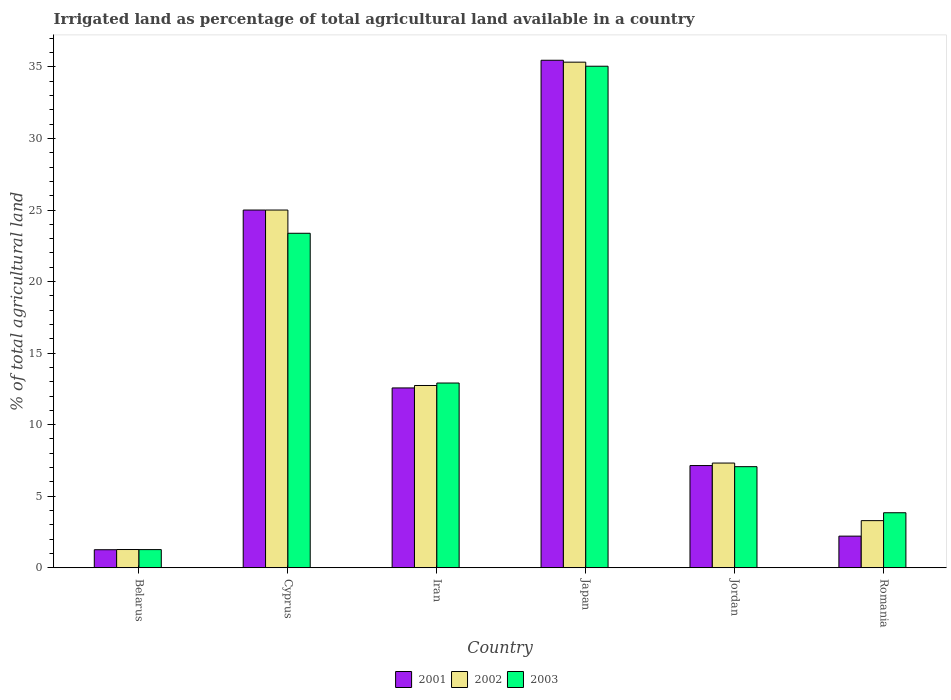How many groups of bars are there?
Give a very brief answer. 6. How many bars are there on the 2nd tick from the left?
Keep it short and to the point. 3. How many bars are there on the 1st tick from the right?
Keep it short and to the point. 3. What is the label of the 2nd group of bars from the left?
Ensure brevity in your answer.  Cyprus. What is the percentage of irrigated land in 2001 in Belarus?
Your response must be concise. 1.26. Across all countries, what is the maximum percentage of irrigated land in 2001?
Your answer should be compact. 35.47. Across all countries, what is the minimum percentage of irrigated land in 2001?
Keep it short and to the point. 1.26. In which country was the percentage of irrigated land in 2002 maximum?
Offer a terse response. Japan. In which country was the percentage of irrigated land in 2002 minimum?
Give a very brief answer. Belarus. What is the total percentage of irrigated land in 2002 in the graph?
Give a very brief answer. 84.96. What is the difference between the percentage of irrigated land in 2001 in Cyprus and that in Iran?
Your answer should be compact. 12.43. What is the difference between the percentage of irrigated land in 2002 in Jordan and the percentage of irrigated land in 2003 in Iran?
Provide a succinct answer. -5.59. What is the average percentage of irrigated land in 2003 per country?
Provide a succinct answer. 13.92. What is the difference between the percentage of irrigated land of/in 2002 and percentage of irrigated land of/in 2001 in Japan?
Your answer should be compact. -0.13. What is the ratio of the percentage of irrigated land in 2001 in Cyprus to that in Jordan?
Offer a terse response. 3.5. What is the difference between the highest and the second highest percentage of irrigated land in 2001?
Your answer should be very brief. -10.47. What is the difference between the highest and the lowest percentage of irrigated land in 2001?
Ensure brevity in your answer.  34.21. What does the 2nd bar from the left in Romania represents?
Make the answer very short. 2002. What does the 3rd bar from the right in Jordan represents?
Offer a very short reply. 2001. What is the difference between two consecutive major ticks on the Y-axis?
Make the answer very short. 5. Are the values on the major ticks of Y-axis written in scientific E-notation?
Keep it short and to the point. No. Does the graph contain any zero values?
Offer a terse response. No. Does the graph contain grids?
Your answer should be very brief. No. Where does the legend appear in the graph?
Ensure brevity in your answer.  Bottom center. What is the title of the graph?
Provide a succinct answer. Irrigated land as percentage of total agricultural land available in a country. What is the label or title of the Y-axis?
Provide a short and direct response. % of total agricultural land. What is the % of total agricultural land of 2001 in Belarus?
Offer a very short reply. 1.26. What is the % of total agricultural land in 2002 in Belarus?
Make the answer very short. 1.27. What is the % of total agricultural land of 2003 in Belarus?
Your response must be concise. 1.27. What is the % of total agricultural land in 2002 in Cyprus?
Offer a terse response. 25. What is the % of total agricultural land of 2003 in Cyprus?
Offer a very short reply. 23.38. What is the % of total agricultural land of 2001 in Iran?
Offer a terse response. 12.57. What is the % of total agricultural land of 2002 in Iran?
Ensure brevity in your answer.  12.74. What is the % of total agricultural land in 2003 in Iran?
Provide a succinct answer. 12.91. What is the % of total agricultural land of 2001 in Japan?
Keep it short and to the point. 35.47. What is the % of total agricultural land of 2002 in Japan?
Provide a short and direct response. 35.33. What is the % of total agricultural land in 2003 in Japan?
Give a very brief answer. 35.05. What is the % of total agricultural land in 2001 in Jordan?
Ensure brevity in your answer.  7.14. What is the % of total agricultural land of 2002 in Jordan?
Provide a short and direct response. 7.32. What is the % of total agricultural land of 2003 in Jordan?
Provide a succinct answer. 7.06. What is the % of total agricultural land of 2001 in Romania?
Provide a succinct answer. 2.21. What is the % of total agricultural land of 2002 in Romania?
Your answer should be very brief. 3.29. What is the % of total agricultural land of 2003 in Romania?
Make the answer very short. 3.84. Across all countries, what is the maximum % of total agricultural land of 2001?
Provide a short and direct response. 35.47. Across all countries, what is the maximum % of total agricultural land of 2002?
Offer a very short reply. 35.33. Across all countries, what is the maximum % of total agricultural land of 2003?
Your answer should be very brief. 35.05. Across all countries, what is the minimum % of total agricultural land in 2001?
Your answer should be compact. 1.26. Across all countries, what is the minimum % of total agricultural land in 2002?
Your response must be concise. 1.27. Across all countries, what is the minimum % of total agricultural land in 2003?
Keep it short and to the point. 1.27. What is the total % of total agricultural land of 2001 in the graph?
Keep it short and to the point. 83.65. What is the total % of total agricultural land in 2002 in the graph?
Keep it short and to the point. 84.96. What is the total % of total agricultural land of 2003 in the graph?
Offer a very short reply. 83.52. What is the difference between the % of total agricultural land in 2001 in Belarus and that in Cyprus?
Provide a succinct answer. -23.74. What is the difference between the % of total agricultural land of 2002 in Belarus and that in Cyprus?
Provide a short and direct response. -23.73. What is the difference between the % of total agricultural land in 2003 in Belarus and that in Cyprus?
Provide a short and direct response. -22.11. What is the difference between the % of total agricultural land of 2001 in Belarus and that in Iran?
Your response must be concise. -11.31. What is the difference between the % of total agricultural land of 2002 in Belarus and that in Iran?
Your answer should be compact. -11.46. What is the difference between the % of total agricultural land in 2003 in Belarus and that in Iran?
Provide a succinct answer. -11.64. What is the difference between the % of total agricultural land in 2001 in Belarus and that in Japan?
Provide a short and direct response. -34.21. What is the difference between the % of total agricultural land in 2002 in Belarus and that in Japan?
Give a very brief answer. -34.06. What is the difference between the % of total agricultural land of 2003 in Belarus and that in Japan?
Keep it short and to the point. -33.78. What is the difference between the % of total agricultural land of 2001 in Belarus and that in Jordan?
Offer a very short reply. -5.88. What is the difference between the % of total agricultural land of 2002 in Belarus and that in Jordan?
Ensure brevity in your answer.  -6.04. What is the difference between the % of total agricultural land in 2003 in Belarus and that in Jordan?
Keep it short and to the point. -5.8. What is the difference between the % of total agricultural land of 2001 in Belarus and that in Romania?
Your response must be concise. -0.95. What is the difference between the % of total agricultural land in 2002 in Belarus and that in Romania?
Provide a succinct answer. -2.02. What is the difference between the % of total agricultural land of 2003 in Belarus and that in Romania?
Ensure brevity in your answer.  -2.58. What is the difference between the % of total agricultural land in 2001 in Cyprus and that in Iran?
Your response must be concise. 12.43. What is the difference between the % of total agricultural land of 2002 in Cyprus and that in Iran?
Ensure brevity in your answer.  12.26. What is the difference between the % of total agricultural land in 2003 in Cyprus and that in Iran?
Offer a very short reply. 10.47. What is the difference between the % of total agricultural land in 2001 in Cyprus and that in Japan?
Make the answer very short. -10.47. What is the difference between the % of total agricultural land in 2002 in Cyprus and that in Japan?
Give a very brief answer. -10.33. What is the difference between the % of total agricultural land of 2003 in Cyprus and that in Japan?
Keep it short and to the point. -11.67. What is the difference between the % of total agricultural land in 2001 in Cyprus and that in Jordan?
Make the answer very short. 17.86. What is the difference between the % of total agricultural land of 2002 in Cyprus and that in Jordan?
Make the answer very short. 17.68. What is the difference between the % of total agricultural land of 2003 in Cyprus and that in Jordan?
Provide a succinct answer. 16.31. What is the difference between the % of total agricultural land of 2001 in Cyprus and that in Romania?
Your response must be concise. 22.79. What is the difference between the % of total agricultural land in 2002 in Cyprus and that in Romania?
Make the answer very short. 21.71. What is the difference between the % of total agricultural land of 2003 in Cyprus and that in Romania?
Offer a very short reply. 19.53. What is the difference between the % of total agricultural land of 2001 in Iran and that in Japan?
Ensure brevity in your answer.  -22.9. What is the difference between the % of total agricultural land in 2002 in Iran and that in Japan?
Ensure brevity in your answer.  -22.6. What is the difference between the % of total agricultural land in 2003 in Iran and that in Japan?
Ensure brevity in your answer.  -22.14. What is the difference between the % of total agricultural land in 2001 in Iran and that in Jordan?
Make the answer very short. 5.42. What is the difference between the % of total agricultural land of 2002 in Iran and that in Jordan?
Make the answer very short. 5.42. What is the difference between the % of total agricultural land in 2003 in Iran and that in Jordan?
Offer a terse response. 5.85. What is the difference between the % of total agricultural land in 2001 in Iran and that in Romania?
Keep it short and to the point. 10.36. What is the difference between the % of total agricultural land of 2002 in Iran and that in Romania?
Offer a very short reply. 9.44. What is the difference between the % of total agricultural land in 2003 in Iran and that in Romania?
Your answer should be very brief. 9.07. What is the difference between the % of total agricultural land of 2001 in Japan and that in Jordan?
Your answer should be very brief. 28.33. What is the difference between the % of total agricultural land in 2002 in Japan and that in Jordan?
Ensure brevity in your answer.  28.02. What is the difference between the % of total agricultural land of 2003 in Japan and that in Jordan?
Make the answer very short. 27.99. What is the difference between the % of total agricultural land of 2001 in Japan and that in Romania?
Offer a terse response. 33.26. What is the difference between the % of total agricultural land of 2002 in Japan and that in Romania?
Your answer should be very brief. 32.04. What is the difference between the % of total agricultural land in 2003 in Japan and that in Romania?
Your response must be concise. 31.21. What is the difference between the % of total agricultural land of 2001 in Jordan and that in Romania?
Your answer should be very brief. 4.93. What is the difference between the % of total agricultural land of 2002 in Jordan and that in Romania?
Make the answer very short. 4.02. What is the difference between the % of total agricultural land in 2003 in Jordan and that in Romania?
Your answer should be very brief. 3.22. What is the difference between the % of total agricultural land of 2001 in Belarus and the % of total agricultural land of 2002 in Cyprus?
Give a very brief answer. -23.74. What is the difference between the % of total agricultural land in 2001 in Belarus and the % of total agricultural land in 2003 in Cyprus?
Make the answer very short. -22.12. What is the difference between the % of total agricultural land in 2002 in Belarus and the % of total agricultural land in 2003 in Cyprus?
Make the answer very short. -22.1. What is the difference between the % of total agricultural land of 2001 in Belarus and the % of total agricultural land of 2002 in Iran?
Make the answer very short. -11.48. What is the difference between the % of total agricultural land of 2001 in Belarus and the % of total agricultural land of 2003 in Iran?
Provide a succinct answer. -11.65. What is the difference between the % of total agricultural land in 2002 in Belarus and the % of total agricultural land in 2003 in Iran?
Provide a succinct answer. -11.64. What is the difference between the % of total agricultural land of 2001 in Belarus and the % of total agricultural land of 2002 in Japan?
Give a very brief answer. -34.08. What is the difference between the % of total agricultural land of 2001 in Belarus and the % of total agricultural land of 2003 in Japan?
Your answer should be very brief. -33.79. What is the difference between the % of total agricultural land in 2002 in Belarus and the % of total agricultural land in 2003 in Japan?
Give a very brief answer. -33.78. What is the difference between the % of total agricultural land in 2001 in Belarus and the % of total agricultural land in 2002 in Jordan?
Ensure brevity in your answer.  -6.06. What is the difference between the % of total agricultural land of 2001 in Belarus and the % of total agricultural land of 2003 in Jordan?
Give a very brief answer. -5.8. What is the difference between the % of total agricultural land of 2002 in Belarus and the % of total agricultural land of 2003 in Jordan?
Give a very brief answer. -5.79. What is the difference between the % of total agricultural land in 2001 in Belarus and the % of total agricultural land in 2002 in Romania?
Your response must be concise. -2.03. What is the difference between the % of total agricultural land of 2001 in Belarus and the % of total agricultural land of 2003 in Romania?
Give a very brief answer. -2.58. What is the difference between the % of total agricultural land in 2002 in Belarus and the % of total agricultural land in 2003 in Romania?
Your answer should be compact. -2.57. What is the difference between the % of total agricultural land of 2001 in Cyprus and the % of total agricultural land of 2002 in Iran?
Give a very brief answer. 12.26. What is the difference between the % of total agricultural land of 2001 in Cyprus and the % of total agricultural land of 2003 in Iran?
Offer a terse response. 12.09. What is the difference between the % of total agricultural land of 2002 in Cyprus and the % of total agricultural land of 2003 in Iran?
Give a very brief answer. 12.09. What is the difference between the % of total agricultural land of 2001 in Cyprus and the % of total agricultural land of 2002 in Japan?
Keep it short and to the point. -10.33. What is the difference between the % of total agricultural land in 2001 in Cyprus and the % of total agricultural land in 2003 in Japan?
Your answer should be compact. -10.05. What is the difference between the % of total agricultural land in 2002 in Cyprus and the % of total agricultural land in 2003 in Japan?
Make the answer very short. -10.05. What is the difference between the % of total agricultural land in 2001 in Cyprus and the % of total agricultural land in 2002 in Jordan?
Your answer should be very brief. 17.68. What is the difference between the % of total agricultural land in 2001 in Cyprus and the % of total agricultural land in 2003 in Jordan?
Your response must be concise. 17.94. What is the difference between the % of total agricultural land in 2002 in Cyprus and the % of total agricultural land in 2003 in Jordan?
Provide a succinct answer. 17.94. What is the difference between the % of total agricultural land in 2001 in Cyprus and the % of total agricultural land in 2002 in Romania?
Your answer should be very brief. 21.71. What is the difference between the % of total agricultural land in 2001 in Cyprus and the % of total agricultural land in 2003 in Romania?
Provide a short and direct response. 21.16. What is the difference between the % of total agricultural land of 2002 in Cyprus and the % of total agricultural land of 2003 in Romania?
Your answer should be very brief. 21.16. What is the difference between the % of total agricultural land in 2001 in Iran and the % of total agricultural land in 2002 in Japan?
Keep it short and to the point. -22.77. What is the difference between the % of total agricultural land in 2001 in Iran and the % of total agricultural land in 2003 in Japan?
Give a very brief answer. -22.48. What is the difference between the % of total agricultural land in 2002 in Iran and the % of total agricultural land in 2003 in Japan?
Keep it short and to the point. -22.31. What is the difference between the % of total agricultural land in 2001 in Iran and the % of total agricultural land in 2002 in Jordan?
Your answer should be compact. 5.25. What is the difference between the % of total agricultural land in 2001 in Iran and the % of total agricultural land in 2003 in Jordan?
Your response must be concise. 5.5. What is the difference between the % of total agricultural land of 2002 in Iran and the % of total agricultural land of 2003 in Jordan?
Your answer should be compact. 5.67. What is the difference between the % of total agricultural land of 2001 in Iran and the % of total agricultural land of 2002 in Romania?
Offer a terse response. 9.27. What is the difference between the % of total agricultural land in 2001 in Iran and the % of total agricultural land in 2003 in Romania?
Your response must be concise. 8.72. What is the difference between the % of total agricultural land of 2002 in Iran and the % of total agricultural land of 2003 in Romania?
Keep it short and to the point. 8.89. What is the difference between the % of total agricultural land of 2001 in Japan and the % of total agricultural land of 2002 in Jordan?
Your response must be concise. 28.15. What is the difference between the % of total agricultural land of 2001 in Japan and the % of total agricultural land of 2003 in Jordan?
Ensure brevity in your answer.  28.4. What is the difference between the % of total agricultural land of 2002 in Japan and the % of total agricultural land of 2003 in Jordan?
Make the answer very short. 28.27. What is the difference between the % of total agricultural land in 2001 in Japan and the % of total agricultural land in 2002 in Romania?
Your answer should be compact. 32.18. What is the difference between the % of total agricultural land of 2001 in Japan and the % of total agricultural land of 2003 in Romania?
Provide a succinct answer. 31.62. What is the difference between the % of total agricultural land of 2002 in Japan and the % of total agricultural land of 2003 in Romania?
Your answer should be very brief. 31.49. What is the difference between the % of total agricultural land in 2001 in Jordan and the % of total agricultural land in 2002 in Romania?
Give a very brief answer. 3.85. What is the difference between the % of total agricultural land of 2001 in Jordan and the % of total agricultural land of 2003 in Romania?
Your answer should be very brief. 3.3. What is the difference between the % of total agricultural land in 2002 in Jordan and the % of total agricultural land in 2003 in Romania?
Give a very brief answer. 3.47. What is the average % of total agricultural land of 2001 per country?
Your response must be concise. 13.94. What is the average % of total agricultural land of 2002 per country?
Keep it short and to the point. 14.16. What is the average % of total agricultural land of 2003 per country?
Ensure brevity in your answer.  13.92. What is the difference between the % of total agricultural land of 2001 and % of total agricultural land of 2002 in Belarus?
Offer a very short reply. -0.01. What is the difference between the % of total agricultural land in 2001 and % of total agricultural land in 2003 in Belarus?
Offer a terse response. -0.01. What is the difference between the % of total agricultural land of 2002 and % of total agricultural land of 2003 in Belarus?
Your response must be concise. 0.01. What is the difference between the % of total agricultural land of 2001 and % of total agricultural land of 2003 in Cyprus?
Your response must be concise. 1.62. What is the difference between the % of total agricultural land of 2002 and % of total agricultural land of 2003 in Cyprus?
Offer a terse response. 1.62. What is the difference between the % of total agricultural land of 2001 and % of total agricultural land of 2002 in Iran?
Offer a terse response. -0.17. What is the difference between the % of total agricultural land of 2001 and % of total agricultural land of 2003 in Iran?
Your response must be concise. -0.34. What is the difference between the % of total agricultural land of 2002 and % of total agricultural land of 2003 in Iran?
Ensure brevity in your answer.  -0.17. What is the difference between the % of total agricultural land in 2001 and % of total agricultural land in 2002 in Japan?
Your answer should be compact. 0.13. What is the difference between the % of total agricultural land in 2001 and % of total agricultural land in 2003 in Japan?
Your answer should be compact. 0.42. What is the difference between the % of total agricultural land in 2002 and % of total agricultural land in 2003 in Japan?
Provide a succinct answer. 0.28. What is the difference between the % of total agricultural land of 2001 and % of total agricultural land of 2002 in Jordan?
Provide a succinct answer. -0.17. What is the difference between the % of total agricultural land in 2001 and % of total agricultural land in 2003 in Jordan?
Ensure brevity in your answer.  0.08. What is the difference between the % of total agricultural land in 2002 and % of total agricultural land in 2003 in Jordan?
Keep it short and to the point. 0.25. What is the difference between the % of total agricultural land of 2001 and % of total agricultural land of 2002 in Romania?
Your response must be concise. -1.08. What is the difference between the % of total agricultural land in 2001 and % of total agricultural land in 2003 in Romania?
Your response must be concise. -1.63. What is the difference between the % of total agricultural land in 2002 and % of total agricultural land in 2003 in Romania?
Your response must be concise. -0.55. What is the ratio of the % of total agricultural land in 2001 in Belarus to that in Cyprus?
Offer a terse response. 0.05. What is the ratio of the % of total agricultural land of 2002 in Belarus to that in Cyprus?
Give a very brief answer. 0.05. What is the ratio of the % of total agricultural land in 2003 in Belarus to that in Cyprus?
Your answer should be compact. 0.05. What is the ratio of the % of total agricultural land in 2001 in Belarus to that in Iran?
Offer a terse response. 0.1. What is the ratio of the % of total agricultural land of 2003 in Belarus to that in Iran?
Ensure brevity in your answer.  0.1. What is the ratio of the % of total agricultural land in 2001 in Belarus to that in Japan?
Offer a very short reply. 0.04. What is the ratio of the % of total agricultural land of 2002 in Belarus to that in Japan?
Your answer should be very brief. 0.04. What is the ratio of the % of total agricultural land of 2003 in Belarus to that in Japan?
Make the answer very short. 0.04. What is the ratio of the % of total agricultural land of 2001 in Belarus to that in Jordan?
Your answer should be very brief. 0.18. What is the ratio of the % of total agricultural land of 2002 in Belarus to that in Jordan?
Provide a succinct answer. 0.17. What is the ratio of the % of total agricultural land of 2003 in Belarus to that in Jordan?
Keep it short and to the point. 0.18. What is the ratio of the % of total agricultural land in 2001 in Belarus to that in Romania?
Provide a short and direct response. 0.57. What is the ratio of the % of total agricultural land of 2002 in Belarus to that in Romania?
Your response must be concise. 0.39. What is the ratio of the % of total agricultural land of 2003 in Belarus to that in Romania?
Give a very brief answer. 0.33. What is the ratio of the % of total agricultural land in 2001 in Cyprus to that in Iran?
Provide a short and direct response. 1.99. What is the ratio of the % of total agricultural land in 2002 in Cyprus to that in Iran?
Keep it short and to the point. 1.96. What is the ratio of the % of total agricultural land of 2003 in Cyprus to that in Iran?
Your answer should be compact. 1.81. What is the ratio of the % of total agricultural land in 2001 in Cyprus to that in Japan?
Give a very brief answer. 0.7. What is the ratio of the % of total agricultural land in 2002 in Cyprus to that in Japan?
Your response must be concise. 0.71. What is the ratio of the % of total agricultural land in 2003 in Cyprus to that in Japan?
Offer a terse response. 0.67. What is the ratio of the % of total agricultural land in 2002 in Cyprus to that in Jordan?
Your answer should be compact. 3.42. What is the ratio of the % of total agricultural land of 2003 in Cyprus to that in Jordan?
Give a very brief answer. 3.31. What is the ratio of the % of total agricultural land of 2001 in Cyprus to that in Romania?
Offer a very short reply. 11.31. What is the ratio of the % of total agricultural land of 2002 in Cyprus to that in Romania?
Provide a short and direct response. 7.59. What is the ratio of the % of total agricultural land in 2003 in Cyprus to that in Romania?
Offer a very short reply. 6.08. What is the ratio of the % of total agricultural land in 2001 in Iran to that in Japan?
Your answer should be very brief. 0.35. What is the ratio of the % of total agricultural land of 2002 in Iran to that in Japan?
Provide a short and direct response. 0.36. What is the ratio of the % of total agricultural land of 2003 in Iran to that in Japan?
Provide a short and direct response. 0.37. What is the ratio of the % of total agricultural land of 2001 in Iran to that in Jordan?
Provide a succinct answer. 1.76. What is the ratio of the % of total agricultural land in 2002 in Iran to that in Jordan?
Keep it short and to the point. 1.74. What is the ratio of the % of total agricultural land in 2003 in Iran to that in Jordan?
Make the answer very short. 1.83. What is the ratio of the % of total agricultural land of 2001 in Iran to that in Romania?
Make the answer very short. 5.69. What is the ratio of the % of total agricultural land in 2002 in Iran to that in Romania?
Give a very brief answer. 3.87. What is the ratio of the % of total agricultural land in 2003 in Iran to that in Romania?
Ensure brevity in your answer.  3.36. What is the ratio of the % of total agricultural land of 2001 in Japan to that in Jordan?
Offer a very short reply. 4.97. What is the ratio of the % of total agricultural land in 2002 in Japan to that in Jordan?
Your answer should be compact. 4.83. What is the ratio of the % of total agricultural land of 2003 in Japan to that in Jordan?
Ensure brevity in your answer.  4.96. What is the ratio of the % of total agricultural land in 2001 in Japan to that in Romania?
Offer a very short reply. 16.05. What is the ratio of the % of total agricultural land in 2002 in Japan to that in Romania?
Give a very brief answer. 10.73. What is the ratio of the % of total agricultural land in 2003 in Japan to that in Romania?
Make the answer very short. 9.12. What is the ratio of the % of total agricultural land in 2001 in Jordan to that in Romania?
Your answer should be very brief. 3.23. What is the ratio of the % of total agricultural land in 2002 in Jordan to that in Romania?
Your answer should be compact. 2.22. What is the ratio of the % of total agricultural land of 2003 in Jordan to that in Romania?
Your answer should be compact. 1.84. What is the difference between the highest and the second highest % of total agricultural land in 2001?
Provide a succinct answer. 10.47. What is the difference between the highest and the second highest % of total agricultural land in 2002?
Offer a very short reply. 10.33. What is the difference between the highest and the second highest % of total agricultural land in 2003?
Provide a short and direct response. 11.67. What is the difference between the highest and the lowest % of total agricultural land of 2001?
Ensure brevity in your answer.  34.21. What is the difference between the highest and the lowest % of total agricultural land of 2002?
Ensure brevity in your answer.  34.06. What is the difference between the highest and the lowest % of total agricultural land in 2003?
Your answer should be very brief. 33.78. 